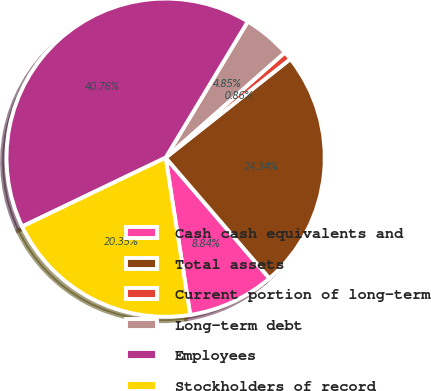Convert chart. <chart><loc_0><loc_0><loc_500><loc_500><pie_chart><fcel>Cash cash equivalents and<fcel>Total assets<fcel>Current portion of long-term<fcel>Long-term debt<fcel>Employees<fcel>Stockholders of record<nl><fcel>8.84%<fcel>24.34%<fcel>0.86%<fcel>4.85%<fcel>40.76%<fcel>20.35%<nl></chart> 